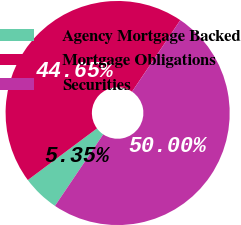Convert chart to OTSL. <chart><loc_0><loc_0><loc_500><loc_500><pie_chart><fcel>Agency Mortgage Backed<fcel>Mortgage Obligations<fcel>Securities<nl><fcel>5.35%<fcel>44.65%<fcel>50.0%<nl></chart> 